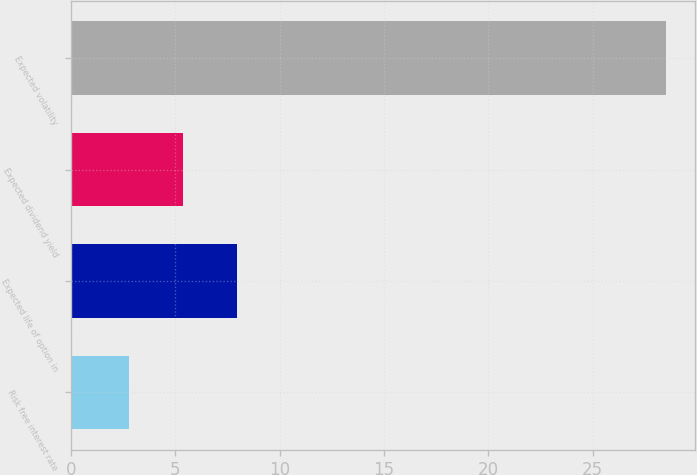Convert chart to OTSL. <chart><loc_0><loc_0><loc_500><loc_500><bar_chart><fcel>Risk free interest rate<fcel>Expected life of option in<fcel>Expected dividend yield<fcel>Expected volatility<nl><fcel>2.8<fcel>7.94<fcel>5.37<fcel>28.5<nl></chart> 